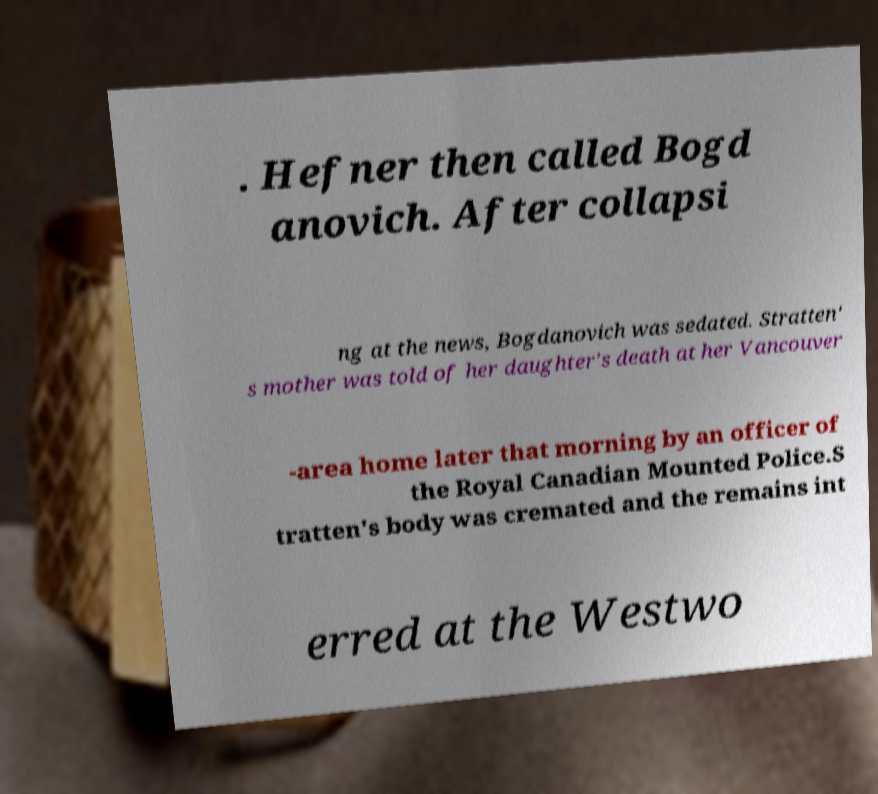Could you assist in decoding the text presented in this image and type it out clearly? . Hefner then called Bogd anovich. After collapsi ng at the news, Bogdanovich was sedated. Stratten' s mother was told of her daughter's death at her Vancouver -area home later that morning by an officer of the Royal Canadian Mounted Police.S tratten's body was cremated and the remains int erred at the Westwo 